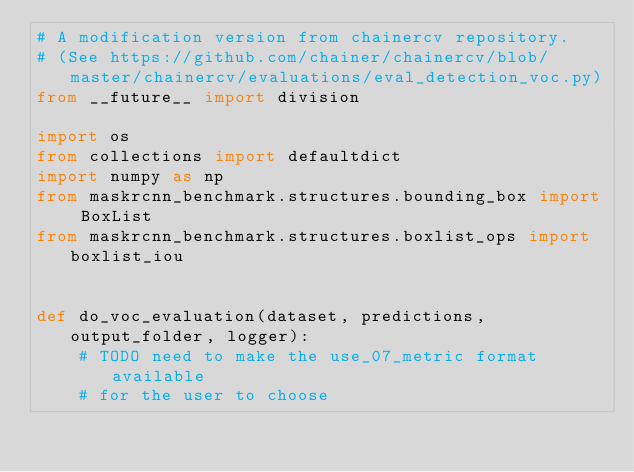<code> <loc_0><loc_0><loc_500><loc_500><_Python_># A modification version from chainercv repository.
# (See https://github.com/chainer/chainercv/blob/master/chainercv/evaluations/eval_detection_voc.py)
from __future__ import division

import os
from collections import defaultdict
import numpy as np
from maskrcnn_benchmark.structures.bounding_box import BoxList
from maskrcnn_benchmark.structures.boxlist_ops import boxlist_iou


def do_voc_evaluation(dataset, predictions, output_folder, logger):
    # TODO need to make the use_07_metric format available
    # for the user to choose</code> 